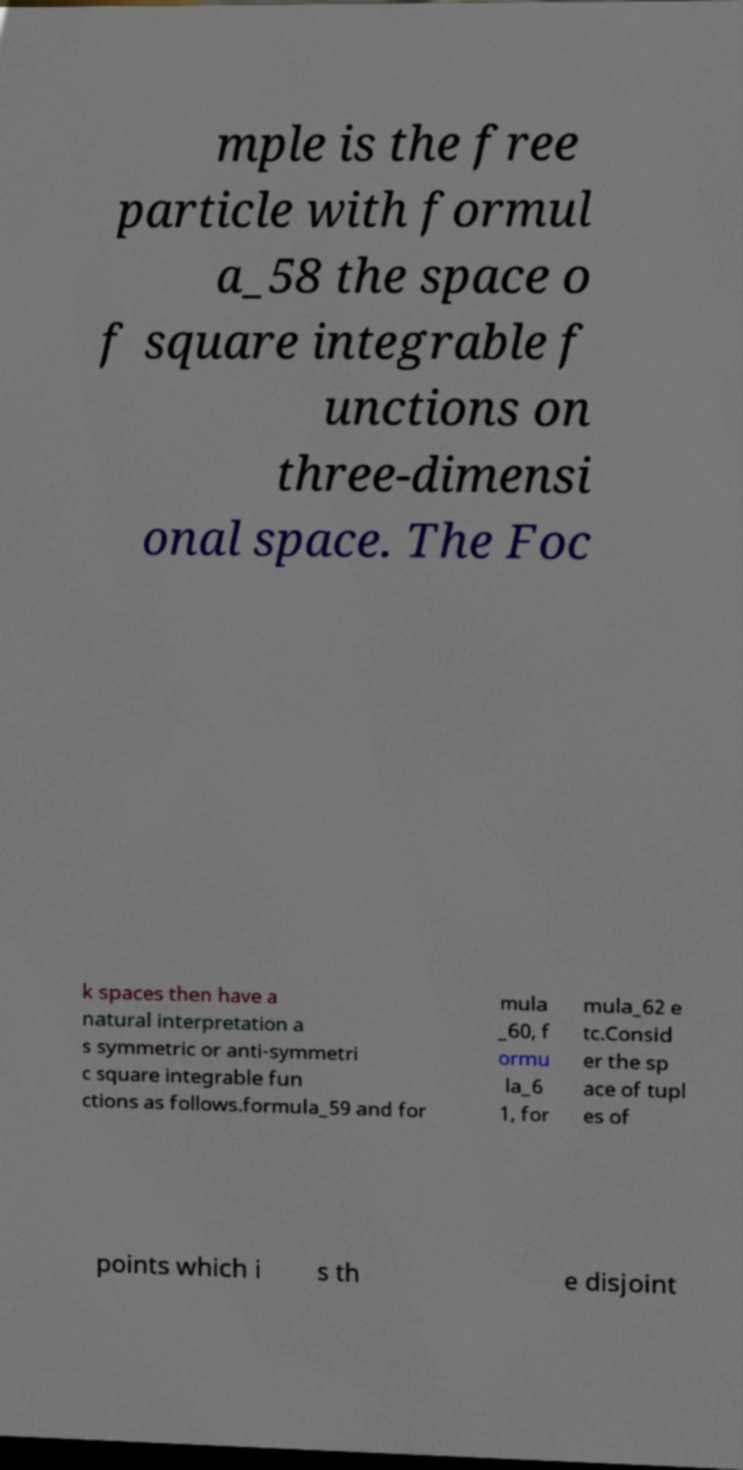I need the written content from this picture converted into text. Can you do that? mple is the free particle with formul a_58 the space o f square integrable f unctions on three-dimensi onal space. The Foc k spaces then have a natural interpretation a s symmetric or anti-symmetri c square integrable fun ctions as follows.formula_59 and for mula _60, f ormu la_6 1, for mula_62 e tc.Consid er the sp ace of tupl es of points which i s th e disjoint 